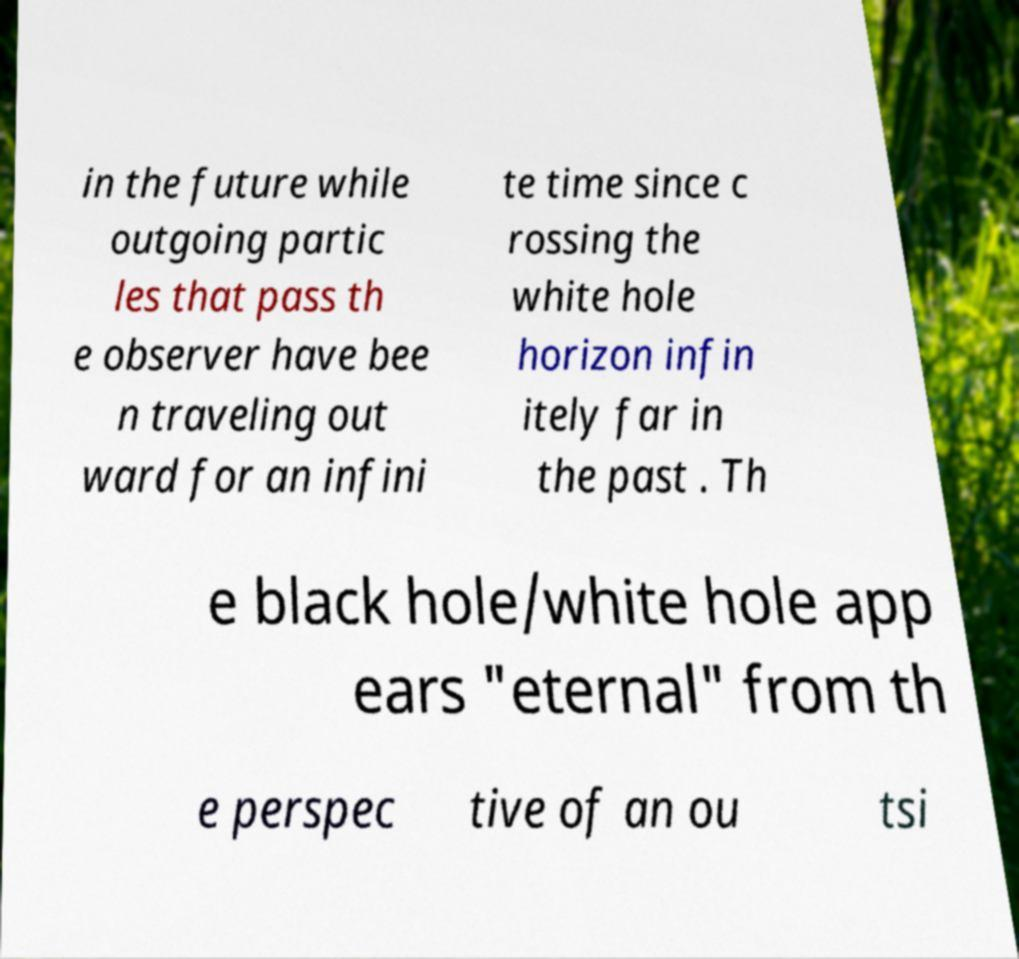Could you assist in decoding the text presented in this image and type it out clearly? in the future while outgoing partic les that pass th e observer have bee n traveling out ward for an infini te time since c rossing the white hole horizon infin itely far in the past . Th e black hole/white hole app ears "eternal" from th e perspec tive of an ou tsi 